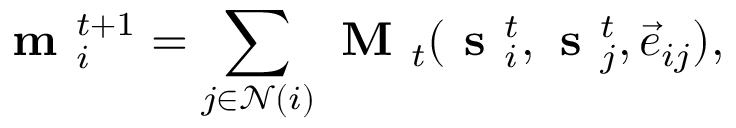Convert formula to latex. <formula><loc_0><loc_0><loc_500><loc_500>m _ { i } ^ { t + 1 } = \sum _ { j \in \mathcal { N } ( i ) } M _ { t } ( s _ { i } ^ { t } , s _ { j } ^ { t } , \vec { e } _ { i j } ) ,</formula> 